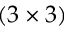Convert formula to latex. <formula><loc_0><loc_0><loc_500><loc_500>( 3 \times 3 )</formula> 